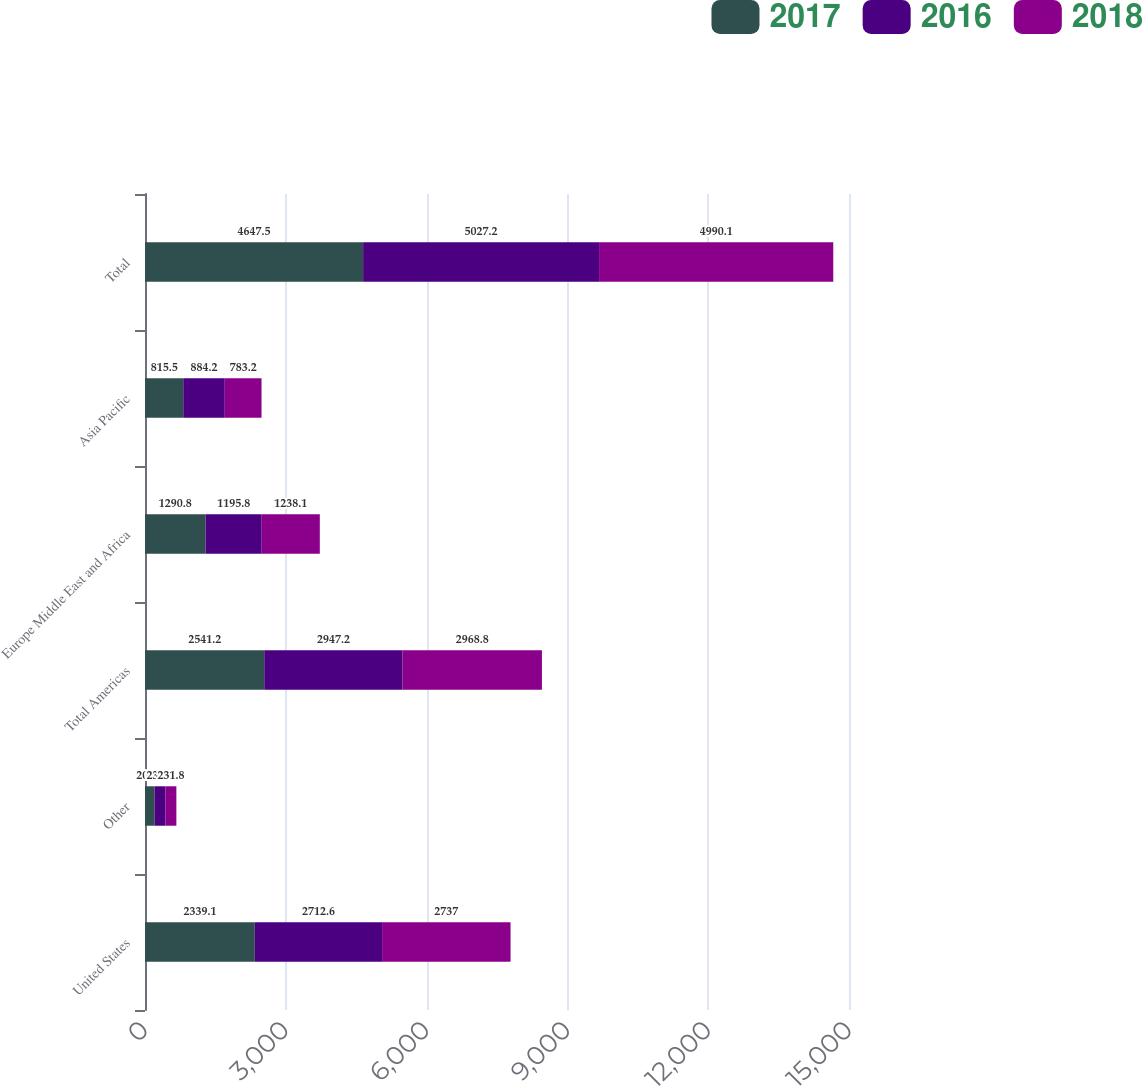Convert chart to OTSL. <chart><loc_0><loc_0><loc_500><loc_500><stacked_bar_chart><ecel><fcel>United States<fcel>Other<fcel>Total Americas<fcel>Europe Middle East and Africa<fcel>Asia Pacific<fcel>Total<nl><fcel>2017<fcel>2339.1<fcel>202.1<fcel>2541.2<fcel>1290.8<fcel>815.5<fcel>4647.5<nl><fcel>2016<fcel>2712.6<fcel>234.6<fcel>2947.2<fcel>1195.8<fcel>884.2<fcel>5027.2<nl><fcel>2018<fcel>2737<fcel>231.8<fcel>2968.8<fcel>1238.1<fcel>783.2<fcel>4990.1<nl></chart> 